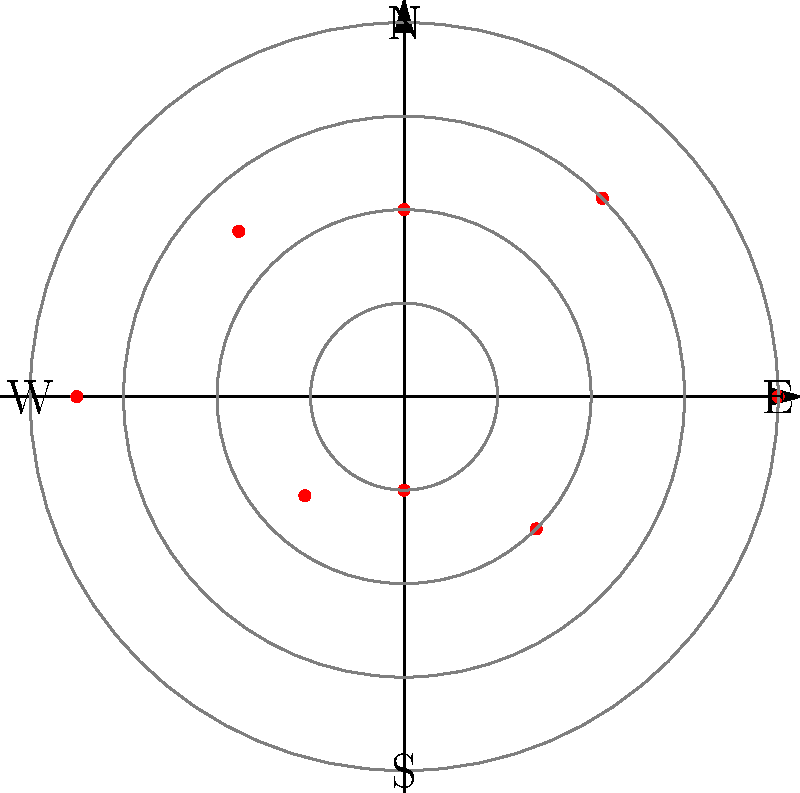Based on the polar plot representing the global distribution of digital piracy hotspots for your latest book, which cardinal direction shows the highest concentration of piracy activity? To determine the cardinal direction with the highest concentration of piracy activity, we need to analyze the polar plot:

1. The plot shows 8 data points, each representing a direction on a compass.
2. The distance from the center represents the intensity of piracy activity.
3. The cardinal directions are labeled as N (North), E (East), S (South), and W (West).
4. We need to identify the longest spoke, which represents the highest value.

Analyzing the spokes:
- North (0°): 8 units
- Northeast (45°): 6 units
- East (90°): 4 units
- Southeast (135°): 5 units
- South (180°): 7 units
- Southwest (225°): 3 units
- West (270°): 2 units
- Northwest (315°): 4 units

The longest spoke is in the North direction, measuring 8 units.

Therefore, the cardinal direction showing the highest concentration of piracy activity is North.
Answer: North 